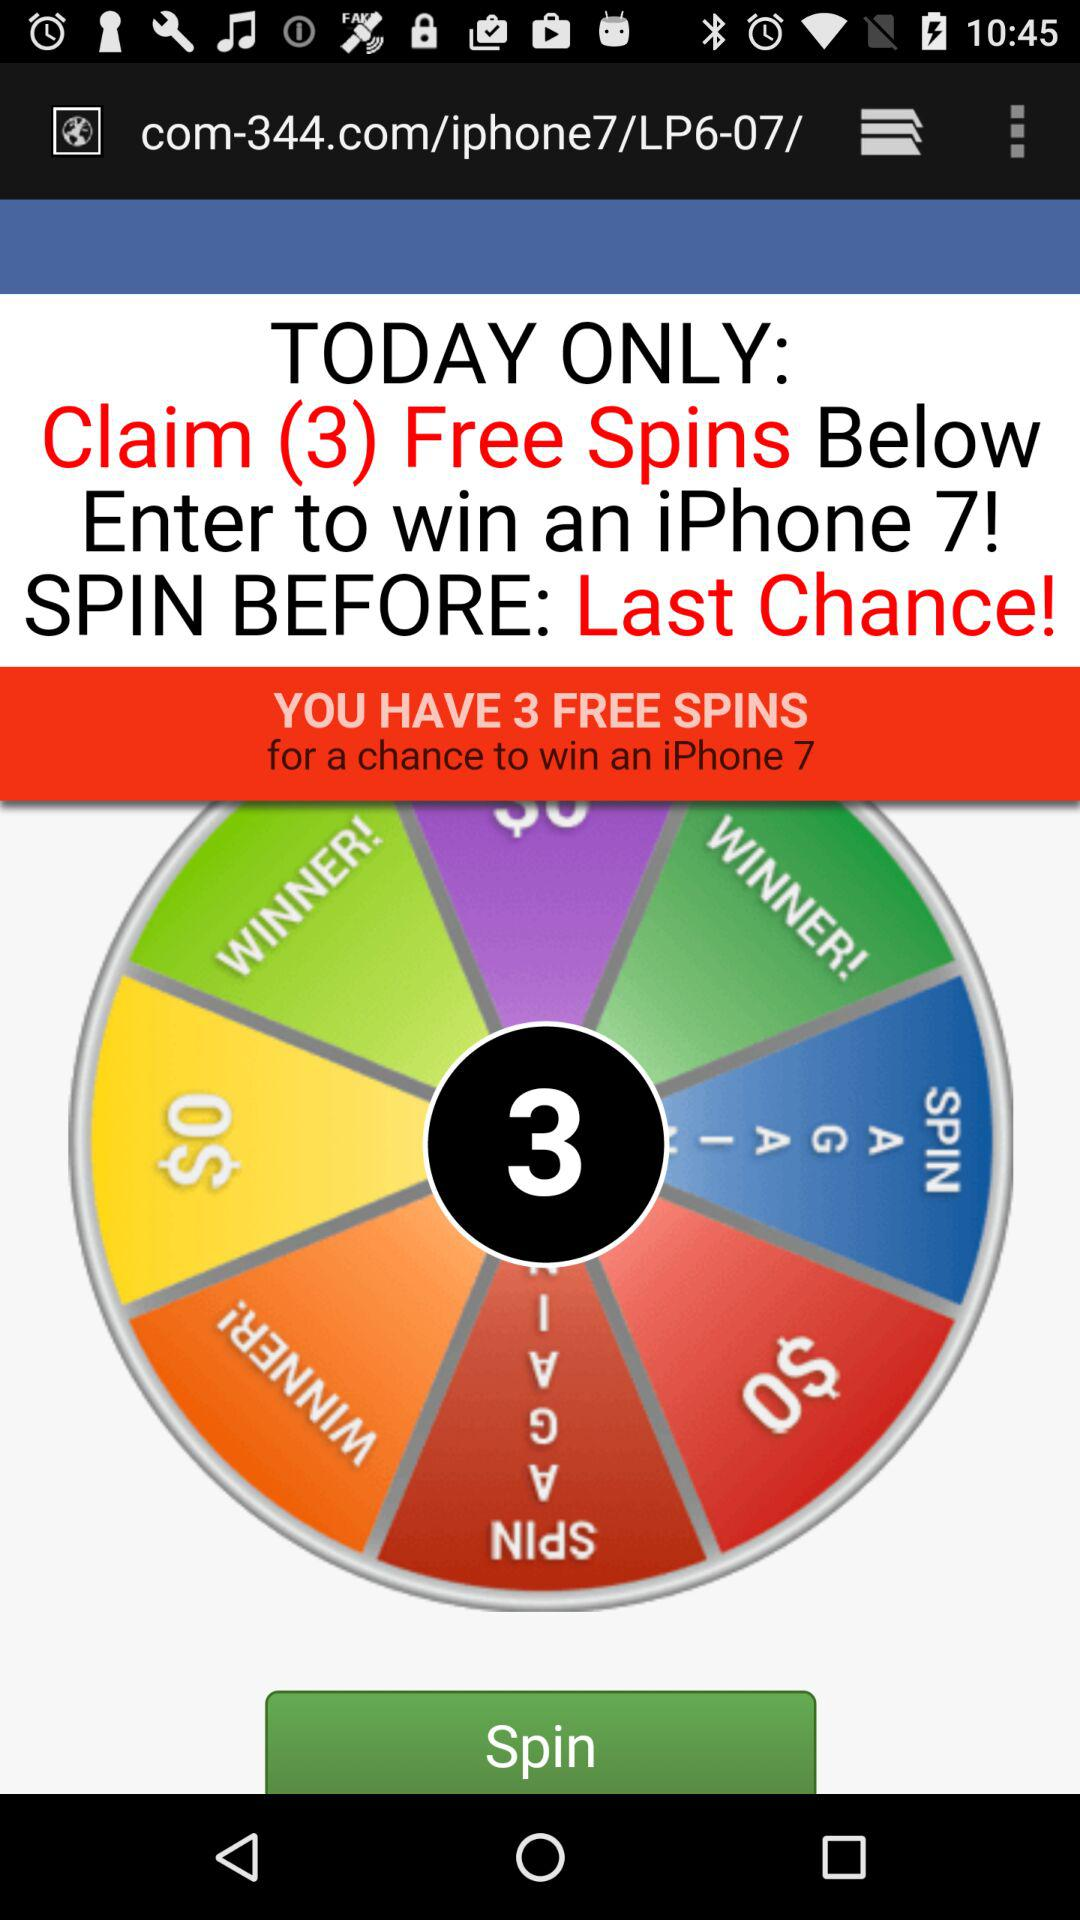How many free spins can be claimed? The number of free spins that can be claimed is 3. 